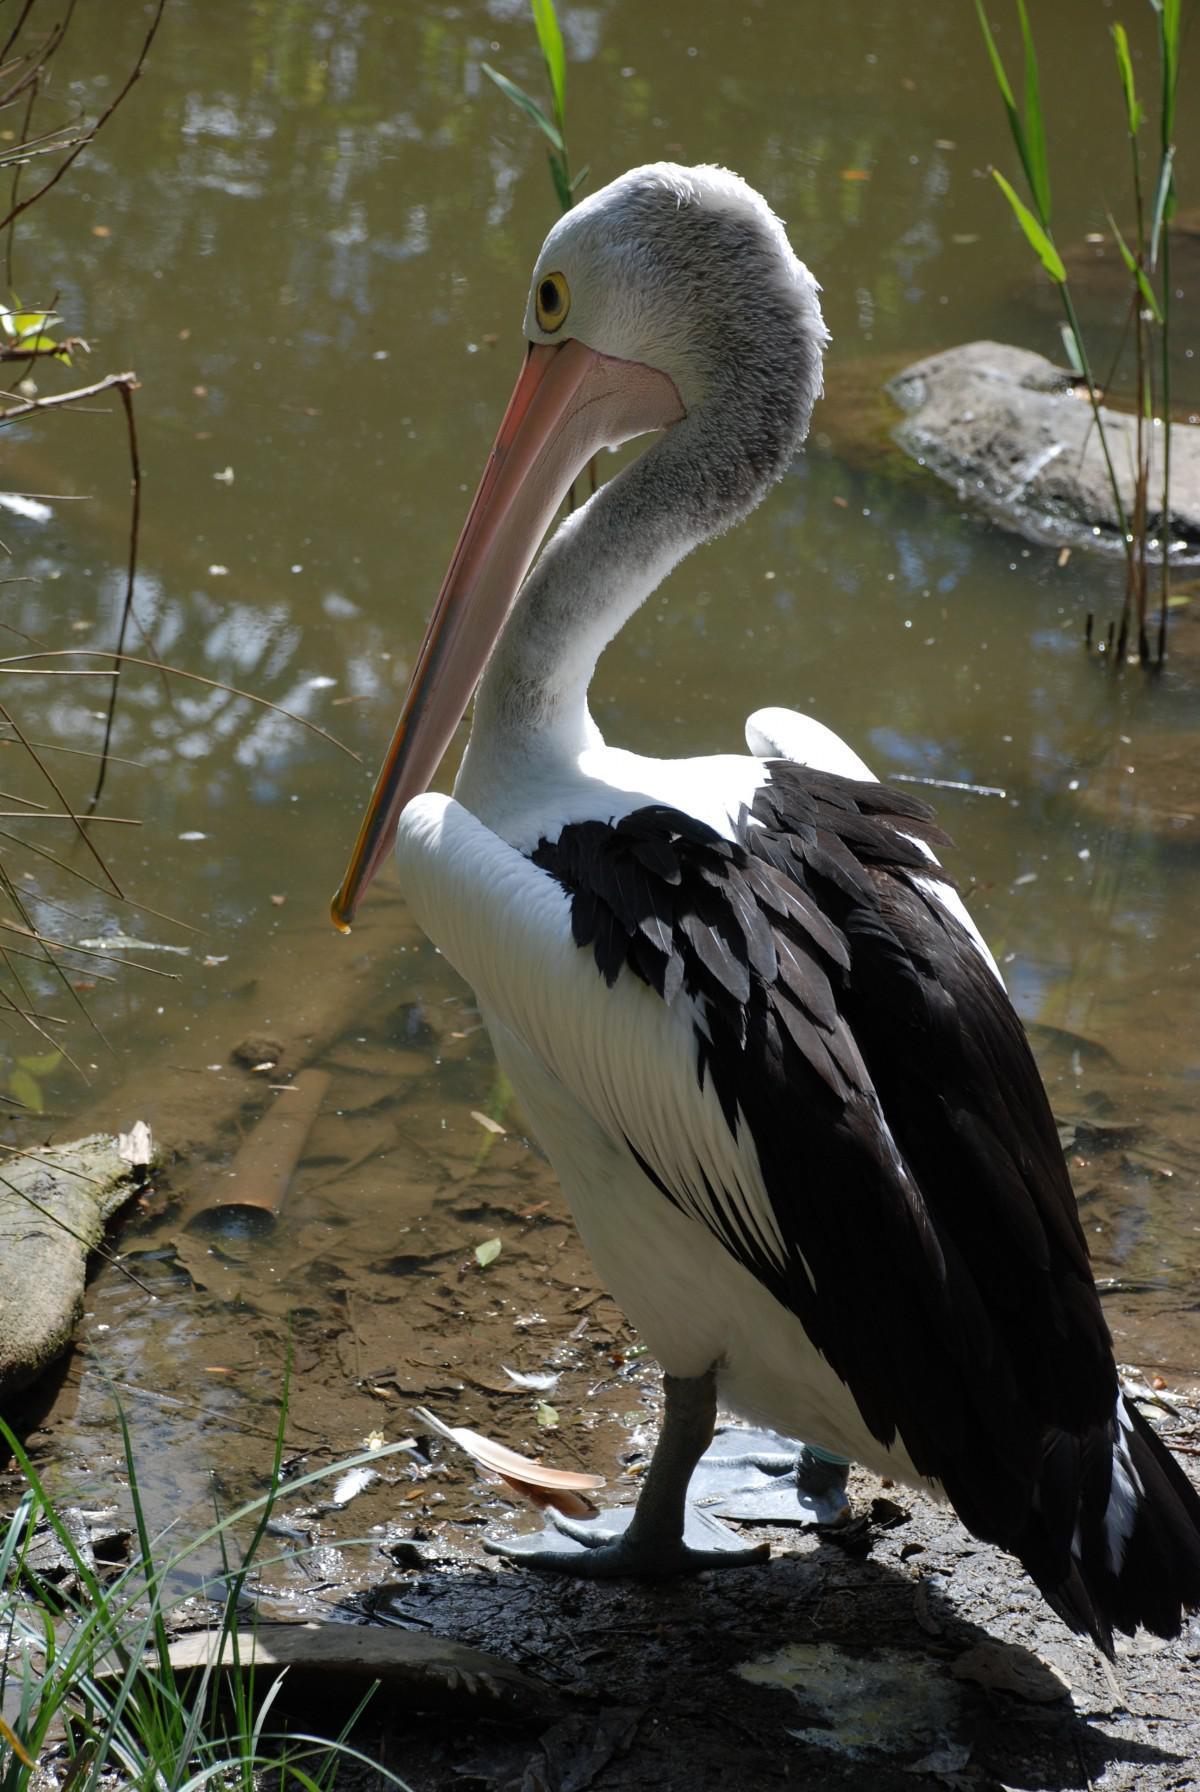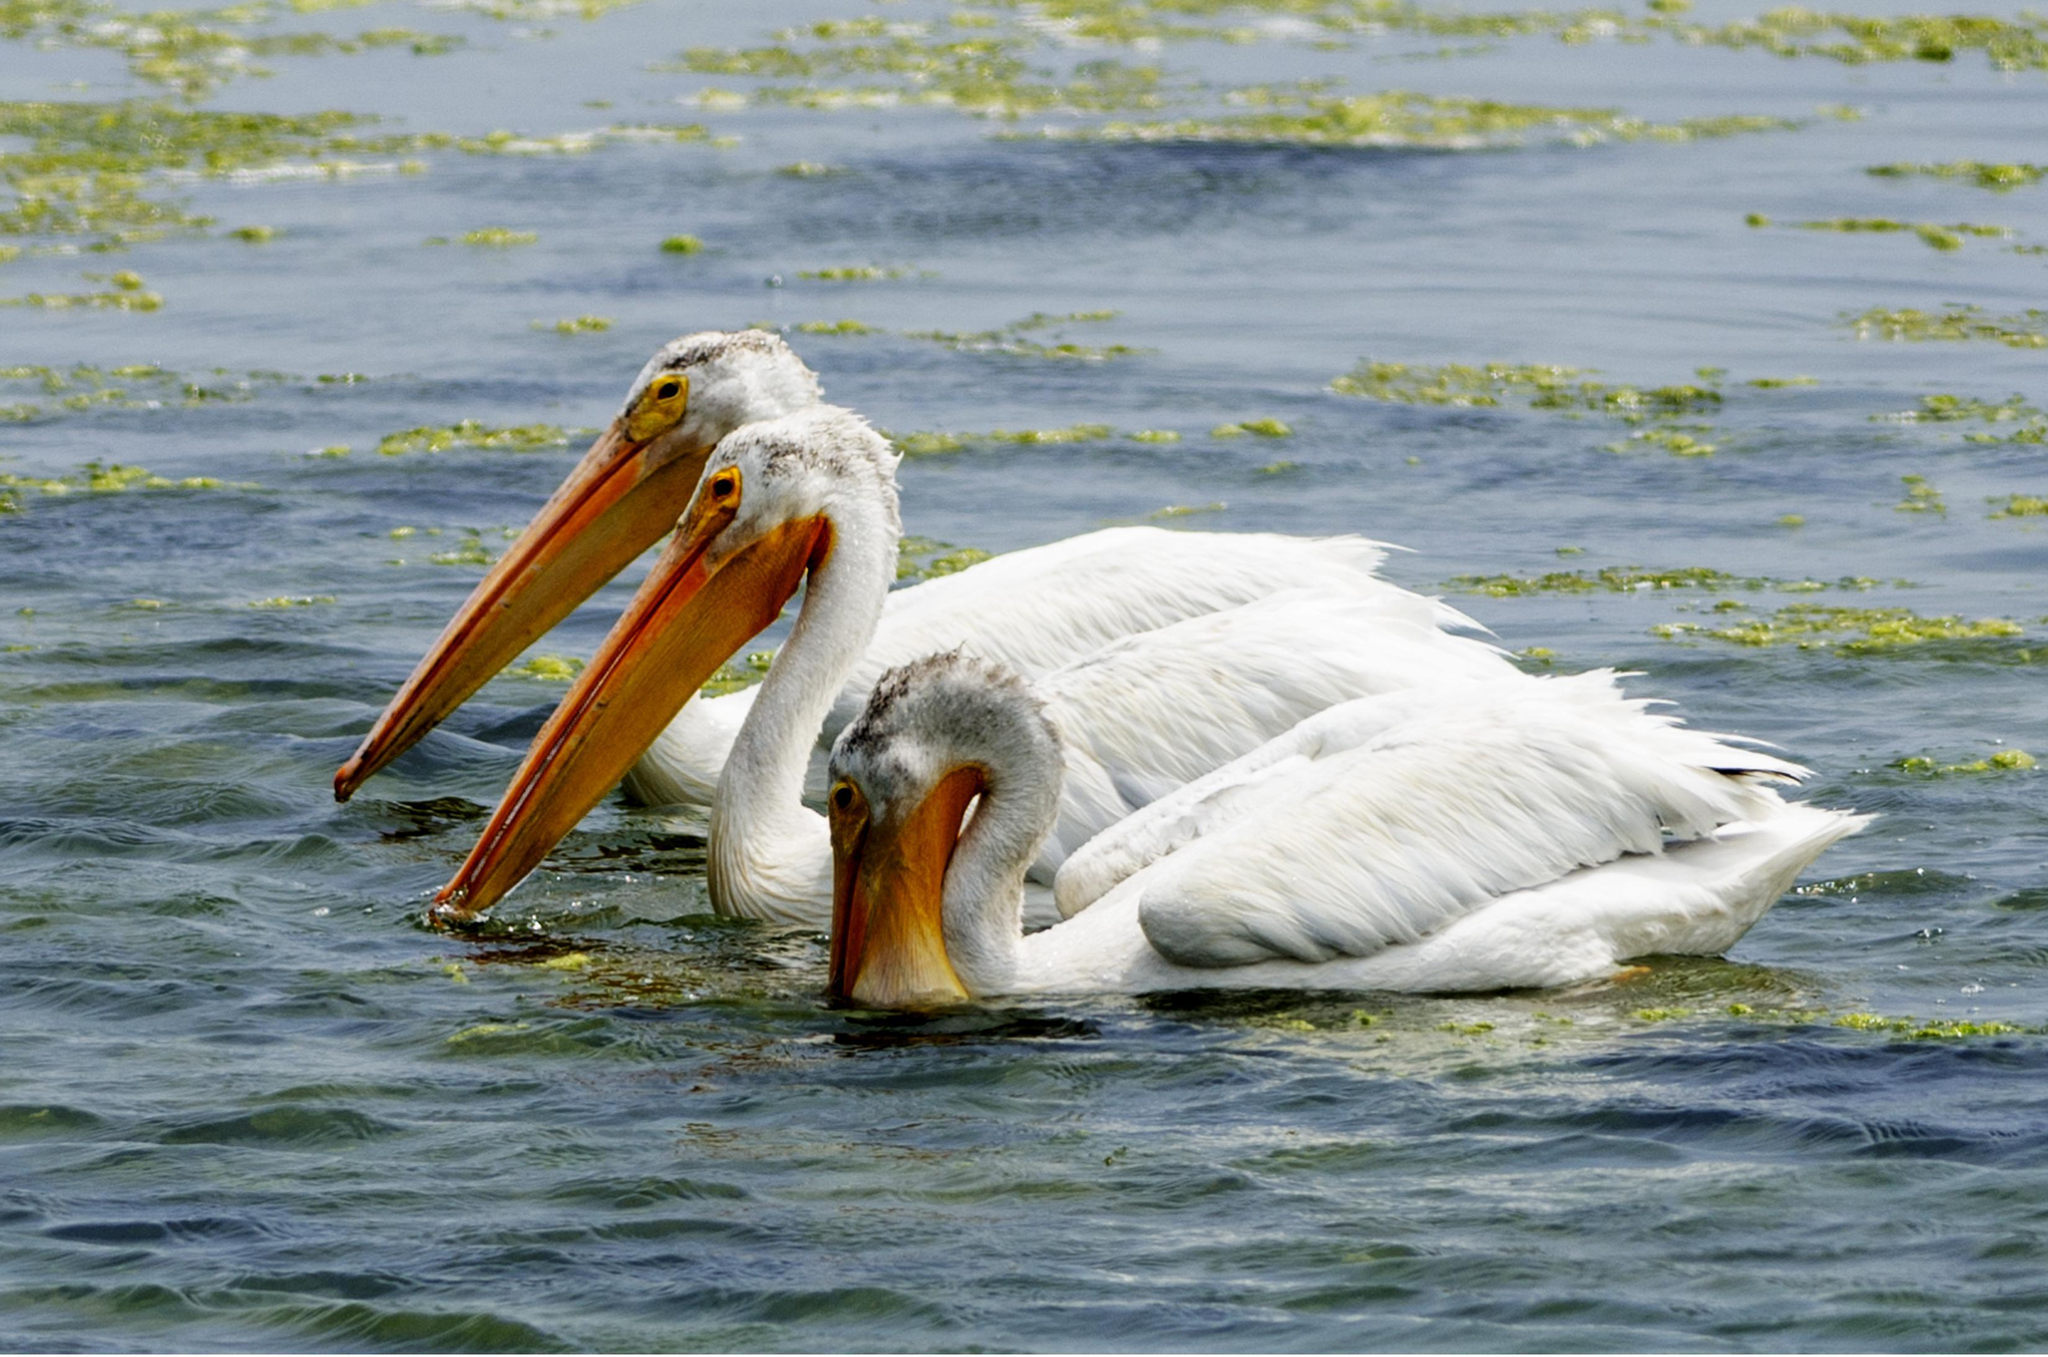The first image is the image on the left, the second image is the image on the right. For the images displayed, is the sentence "There are at least three birds standing on a dock." factually correct? Answer yes or no. No. The first image is the image on the left, the second image is the image on the right. For the images shown, is this caption "One of the images contains a single bird only." true? Answer yes or no. Yes. 